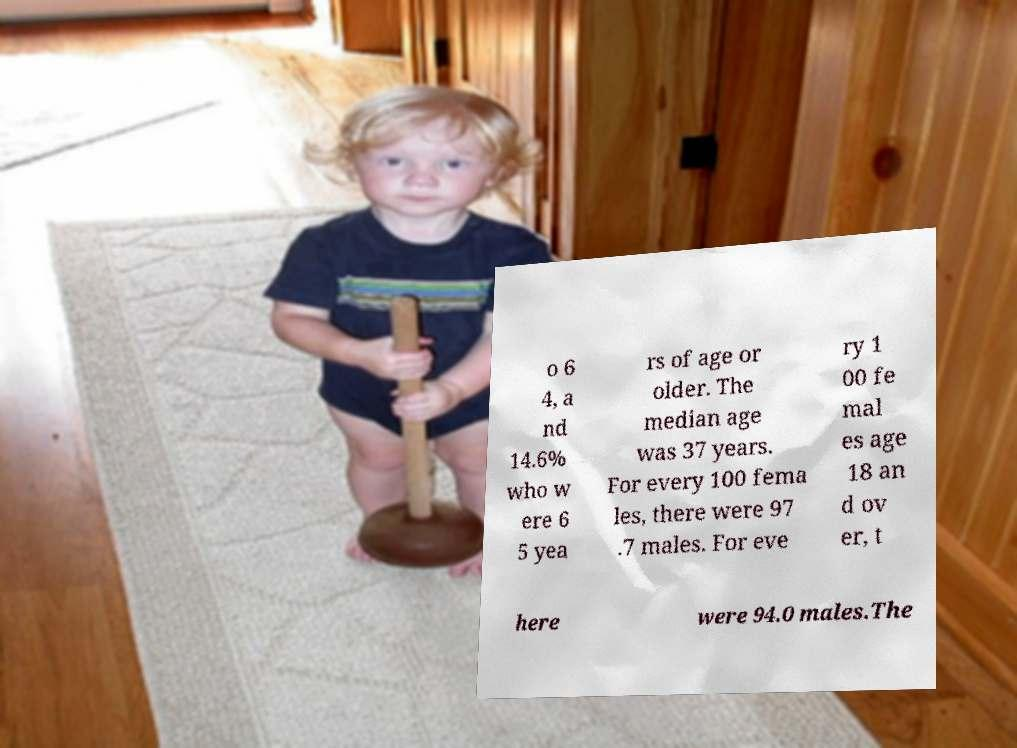What messages or text are displayed in this image? I need them in a readable, typed format. o 6 4, a nd 14.6% who w ere 6 5 yea rs of age or older. The median age was 37 years. For every 100 fema les, there were 97 .7 males. For eve ry 1 00 fe mal es age 18 an d ov er, t here were 94.0 males.The 